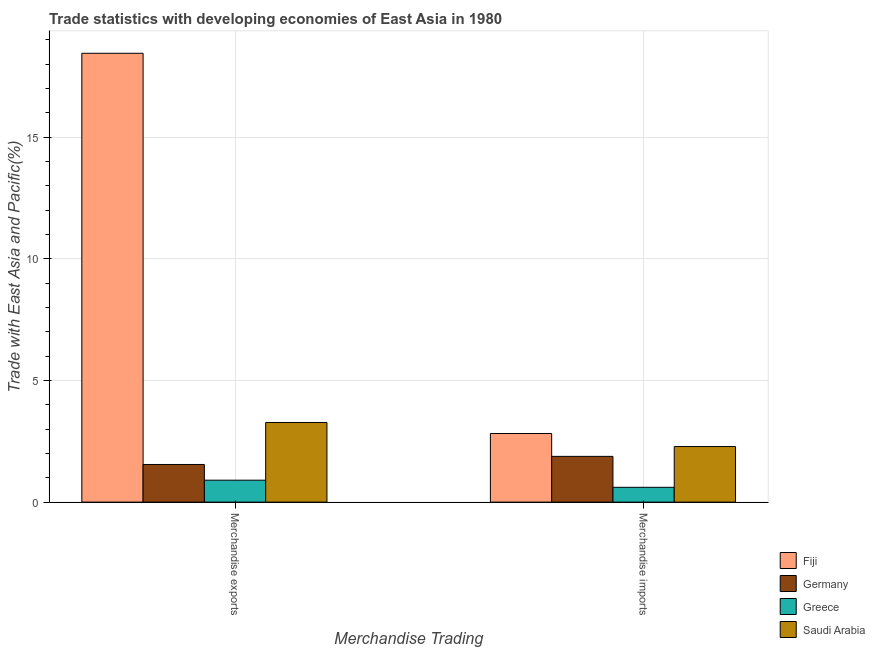How many different coloured bars are there?
Give a very brief answer. 4. Are the number of bars on each tick of the X-axis equal?
Ensure brevity in your answer.  Yes. How many bars are there on the 2nd tick from the left?
Your answer should be compact. 4. How many bars are there on the 1st tick from the right?
Keep it short and to the point. 4. What is the label of the 1st group of bars from the left?
Your response must be concise. Merchandise exports. What is the merchandise exports in Germany?
Offer a very short reply. 1.55. Across all countries, what is the maximum merchandise imports?
Ensure brevity in your answer.  2.82. Across all countries, what is the minimum merchandise imports?
Offer a very short reply. 0.61. In which country was the merchandise exports maximum?
Your response must be concise. Fiji. What is the total merchandise imports in the graph?
Your response must be concise. 7.6. What is the difference between the merchandise imports in Saudi Arabia and that in Greece?
Offer a very short reply. 1.68. What is the difference between the merchandise imports in Saudi Arabia and the merchandise exports in Germany?
Keep it short and to the point. 0.74. What is the average merchandise exports per country?
Provide a succinct answer. 6.04. What is the difference between the merchandise imports and merchandise exports in Saudi Arabia?
Your answer should be compact. -0.99. What is the ratio of the merchandise exports in Fiji to that in Germany?
Your answer should be very brief. 11.92. Is the merchandise imports in Fiji less than that in Greece?
Your answer should be very brief. No. In how many countries, is the merchandise imports greater than the average merchandise imports taken over all countries?
Your response must be concise. 2. How many bars are there?
Provide a short and direct response. 8. Are all the bars in the graph horizontal?
Offer a terse response. No. What is the difference between two consecutive major ticks on the Y-axis?
Provide a short and direct response. 5. What is the title of the graph?
Your response must be concise. Trade statistics with developing economies of East Asia in 1980. What is the label or title of the X-axis?
Give a very brief answer. Merchandise Trading. What is the label or title of the Y-axis?
Keep it short and to the point. Trade with East Asia and Pacific(%). What is the Trade with East Asia and Pacific(%) of Fiji in Merchandise exports?
Offer a terse response. 18.45. What is the Trade with East Asia and Pacific(%) in Germany in Merchandise exports?
Provide a succinct answer. 1.55. What is the Trade with East Asia and Pacific(%) of Greece in Merchandise exports?
Make the answer very short. 0.9. What is the Trade with East Asia and Pacific(%) of Saudi Arabia in Merchandise exports?
Make the answer very short. 3.27. What is the Trade with East Asia and Pacific(%) in Fiji in Merchandise imports?
Give a very brief answer. 2.82. What is the Trade with East Asia and Pacific(%) in Germany in Merchandise imports?
Your response must be concise. 1.88. What is the Trade with East Asia and Pacific(%) in Greece in Merchandise imports?
Ensure brevity in your answer.  0.61. What is the Trade with East Asia and Pacific(%) in Saudi Arabia in Merchandise imports?
Provide a succinct answer. 2.28. Across all Merchandise Trading, what is the maximum Trade with East Asia and Pacific(%) in Fiji?
Keep it short and to the point. 18.45. Across all Merchandise Trading, what is the maximum Trade with East Asia and Pacific(%) in Germany?
Provide a succinct answer. 1.88. Across all Merchandise Trading, what is the maximum Trade with East Asia and Pacific(%) of Greece?
Provide a short and direct response. 0.9. Across all Merchandise Trading, what is the maximum Trade with East Asia and Pacific(%) of Saudi Arabia?
Make the answer very short. 3.27. Across all Merchandise Trading, what is the minimum Trade with East Asia and Pacific(%) in Fiji?
Provide a short and direct response. 2.82. Across all Merchandise Trading, what is the minimum Trade with East Asia and Pacific(%) of Germany?
Ensure brevity in your answer.  1.55. Across all Merchandise Trading, what is the minimum Trade with East Asia and Pacific(%) of Greece?
Offer a terse response. 0.61. Across all Merchandise Trading, what is the minimum Trade with East Asia and Pacific(%) in Saudi Arabia?
Offer a very short reply. 2.28. What is the total Trade with East Asia and Pacific(%) of Fiji in the graph?
Keep it short and to the point. 21.27. What is the total Trade with East Asia and Pacific(%) of Germany in the graph?
Your response must be concise. 3.43. What is the total Trade with East Asia and Pacific(%) of Greece in the graph?
Ensure brevity in your answer.  1.51. What is the total Trade with East Asia and Pacific(%) of Saudi Arabia in the graph?
Give a very brief answer. 5.56. What is the difference between the Trade with East Asia and Pacific(%) of Fiji in Merchandise exports and that in Merchandise imports?
Make the answer very short. 15.63. What is the difference between the Trade with East Asia and Pacific(%) of Germany in Merchandise exports and that in Merchandise imports?
Give a very brief answer. -0.33. What is the difference between the Trade with East Asia and Pacific(%) of Greece in Merchandise exports and that in Merchandise imports?
Offer a terse response. 0.29. What is the difference between the Trade with East Asia and Pacific(%) in Saudi Arabia in Merchandise exports and that in Merchandise imports?
Offer a terse response. 0.99. What is the difference between the Trade with East Asia and Pacific(%) of Fiji in Merchandise exports and the Trade with East Asia and Pacific(%) of Germany in Merchandise imports?
Provide a short and direct response. 16.57. What is the difference between the Trade with East Asia and Pacific(%) of Fiji in Merchandise exports and the Trade with East Asia and Pacific(%) of Greece in Merchandise imports?
Offer a very short reply. 17.84. What is the difference between the Trade with East Asia and Pacific(%) of Fiji in Merchandise exports and the Trade with East Asia and Pacific(%) of Saudi Arabia in Merchandise imports?
Provide a succinct answer. 16.16. What is the difference between the Trade with East Asia and Pacific(%) in Germany in Merchandise exports and the Trade with East Asia and Pacific(%) in Greece in Merchandise imports?
Provide a succinct answer. 0.94. What is the difference between the Trade with East Asia and Pacific(%) in Germany in Merchandise exports and the Trade with East Asia and Pacific(%) in Saudi Arabia in Merchandise imports?
Your response must be concise. -0.74. What is the difference between the Trade with East Asia and Pacific(%) of Greece in Merchandise exports and the Trade with East Asia and Pacific(%) of Saudi Arabia in Merchandise imports?
Your answer should be very brief. -1.38. What is the average Trade with East Asia and Pacific(%) of Fiji per Merchandise Trading?
Provide a succinct answer. 10.63. What is the average Trade with East Asia and Pacific(%) of Germany per Merchandise Trading?
Keep it short and to the point. 1.71. What is the average Trade with East Asia and Pacific(%) of Greece per Merchandise Trading?
Keep it short and to the point. 0.76. What is the average Trade with East Asia and Pacific(%) in Saudi Arabia per Merchandise Trading?
Offer a terse response. 2.78. What is the difference between the Trade with East Asia and Pacific(%) in Fiji and Trade with East Asia and Pacific(%) in Germany in Merchandise exports?
Your response must be concise. 16.9. What is the difference between the Trade with East Asia and Pacific(%) of Fiji and Trade with East Asia and Pacific(%) of Greece in Merchandise exports?
Your answer should be very brief. 17.55. What is the difference between the Trade with East Asia and Pacific(%) in Fiji and Trade with East Asia and Pacific(%) in Saudi Arabia in Merchandise exports?
Your answer should be compact. 15.18. What is the difference between the Trade with East Asia and Pacific(%) of Germany and Trade with East Asia and Pacific(%) of Greece in Merchandise exports?
Offer a terse response. 0.65. What is the difference between the Trade with East Asia and Pacific(%) in Germany and Trade with East Asia and Pacific(%) in Saudi Arabia in Merchandise exports?
Offer a terse response. -1.73. What is the difference between the Trade with East Asia and Pacific(%) of Greece and Trade with East Asia and Pacific(%) of Saudi Arabia in Merchandise exports?
Keep it short and to the point. -2.37. What is the difference between the Trade with East Asia and Pacific(%) in Fiji and Trade with East Asia and Pacific(%) in Germany in Merchandise imports?
Make the answer very short. 0.94. What is the difference between the Trade with East Asia and Pacific(%) in Fiji and Trade with East Asia and Pacific(%) in Greece in Merchandise imports?
Give a very brief answer. 2.21. What is the difference between the Trade with East Asia and Pacific(%) in Fiji and Trade with East Asia and Pacific(%) in Saudi Arabia in Merchandise imports?
Offer a very short reply. 0.54. What is the difference between the Trade with East Asia and Pacific(%) of Germany and Trade with East Asia and Pacific(%) of Greece in Merchandise imports?
Make the answer very short. 1.27. What is the difference between the Trade with East Asia and Pacific(%) in Germany and Trade with East Asia and Pacific(%) in Saudi Arabia in Merchandise imports?
Ensure brevity in your answer.  -0.4. What is the difference between the Trade with East Asia and Pacific(%) of Greece and Trade with East Asia and Pacific(%) of Saudi Arabia in Merchandise imports?
Offer a terse response. -1.68. What is the ratio of the Trade with East Asia and Pacific(%) of Fiji in Merchandise exports to that in Merchandise imports?
Provide a short and direct response. 6.54. What is the ratio of the Trade with East Asia and Pacific(%) in Germany in Merchandise exports to that in Merchandise imports?
Your answer should be very brief. 0.82. What is the ratio of the Trade with East Asia and Pacific(%) of Greece in Merchandise exports to that in Merchandise imports?
Offer a terse response. 1.48. What is the ratio of the Trade with East Asia and Pacific(%) in Saudi Arabia in Merchandise exports to that in Merchandise imports?
Offer a very short reply. 1.43. What is the difference between the highest and the second highest Trade with East Asia and Pacific(%) of Fiji?
Your response must be concise. 15.63. What is the difference between the highest and the second highest Trade with East Asia and Pacific(%) in Germany?
Offer a very short reply. 0.33. What is the difference between the highest and the second highest Trade with East Asia and Pacific(%) in Greece?
Offer a terse response. 0.29. What is the difference between the highest and the second highest Trade with East Asia and Pacific(%) of Saudi Arabia?
Give a very brief answer. 0.99. What is the difference between the highest and the lowest Trade with East Asia and Pacific(%) of Fiji?
Offer a terse response. 15.63. What is the difference between the highest and the lowest Trade with East Asia and Pacific(%) of Germany?
Provide a succinct answer. 0.33. What is the difference between the highest and the lowest Trade with East Asia and Pacific(%) of Greece?
Ensure brevity in your answer.  0.29. What is the difference between the highest and the lowest Trade with East Asia and Pacific(%) in Saudi Arabia?
Make the answer very short. 0.99. 